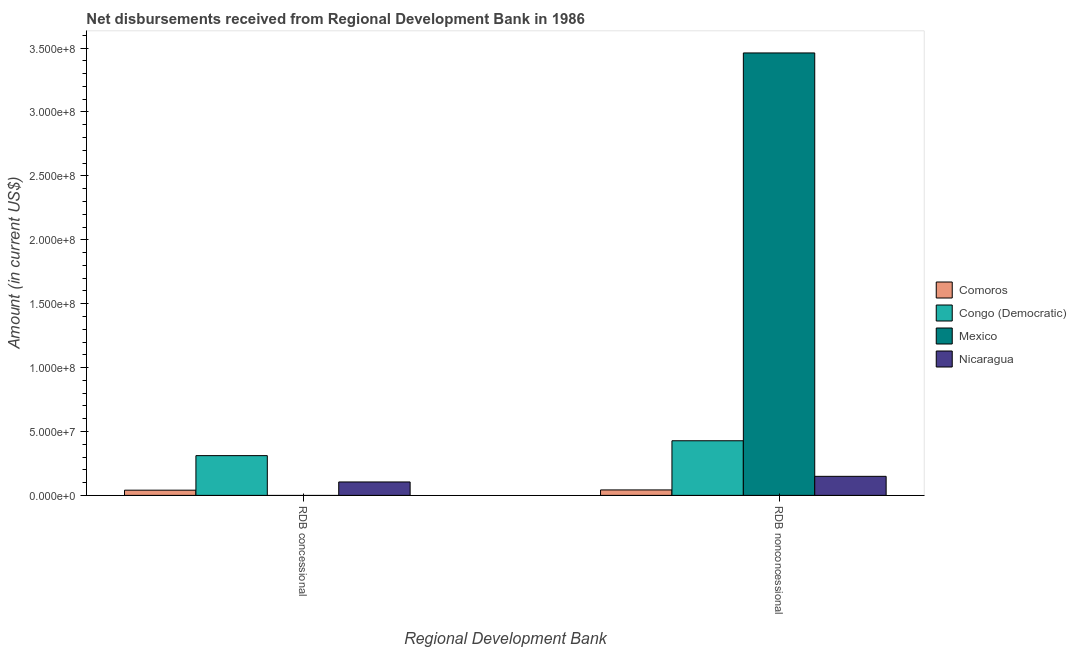Are the number of bars per tick equal to the number of legend labels?
Your answer should be compact. No. Are the number of bars on each tick of the X-axis equal?
Keep it short and to the point. No. How many bars are there on the 1st tick from the left?
Provide a short and direct response. 3. How many bars are there on the 1st tick from the right?
Keep it short and to the point. 4. What is the label of the 2nd group of bars from the left?
Provide a short and direct response. RDB nonconcessional. What is the net non concessional disbursements from rdb in Comoros?
Offer a very short reply. 4.27e+06. Across all countries, what is the maximum net non concessional disbursements from rdb?
Keep it short and to the point. 3.46e+08. In which country was the net concessional disbursements from rdb maximum?
Provide a short and direct response. Congo (Democratic). What is the total net non concessional disbursements from rdb in the graph?
Give a very brief answer. 4.08e+08. What is the difference between the net concessional disbursements from rdb in Nicaragua and that in Comoros?
Your answer should be very brief. 6.43e+06. What is the difference between the net concessional disbursements from rdb in Mexico and the net non concessional disbursements from rdb in Nicaragua?
Provide a succinct answer. -1.49e+07. What is the average net concessional disbursements from rdb per country?
Offer a terse response. 1.14e+07. What is the difference between the net non concessional disbursements from rdb and net concessional disbursements from rdb in Comoros?
Provide a succinct answer. 1.97e+05. What is the ratio of the net non concessional disbursements from rdb in Congo (Democratic) to that in Comoros?
Provide a succinct answer. 10. What is the difference between two consecutive major ticks on the Y-axis?
Keep it short and to the point. 5.00e+07. Are the values on the major ticks of Y-axis written in scientific E-notation?
Make the answer very short. Yes. Does the graph contain any zero values?
Offer a very short reply. Yes. Does the graph contain grids?
Keep it short and to the point. No. How are the legend labels stacked?
Offer a terse response. Vertical. What is the title of the graph?
Give a very brief answer. Net disbursements received from Regional Development Bank in 1986. Does "Tonga" appear as one of the legend labels in the graph?
Give a very brief answer. No. What is the label or title of the X-axis?
Provide a succinct answer. Regional Development Bank. What is the Amount (in current US$) of Comoros in RDB concessional?
Make the answer very short. 4.08e+06. What is the Amount (in current US$) in Congo (Democratic) in RDB concessional?
Give a very brief answer. 3.11e+07. What is the Amount (in current US$) in Mexico in RDB concessional?
Your response must be concise. 0. What is the Amount (in current US$) in Nicaragua in RDB concessional?
Offer a terse response. 1.05e+07. What is the Amount (in current US$) in Comoros in RDB nonconcessional?
Your response must be concise. 4.27e+06. What is the Amount (in current US$) of Congo (Democratic) in RDB nonconcessional?
Your response must be concise. 4.27e+07. What is the Amount (in current US$) in Mexico in RDB nonconcessional?
Make the answer very short. 3.46e+08. What is the Amount (in current US$) of Nicaragua in RDB nonconcessional?
Provide a short and direct response. 1.49e+07. Across all Regional Development Bank, what is the maximum Amount (in current US$) of Comoros?
Provide a short and direct response. 4.27e+06. Across all Regional Development Bank, what is the maximum Amount (in current US$) of Congo (Democratic)?
Your answer should be very brief. 4.27e+07. Across all Regional Development Bank, what is the maximum Amount (in current US$) in Mexico?
Make the answer very short. 3.46e+08. Across all Regional Development Bank, what is the maximum Amount (in current US$) in Nicaragua?
Offer a terse response. 1.49e+07. Across all Regional Development Bank, what is the minimum Amount (in current US$) in Comoros?
Your response must be concise. 4.08e+06. Across all Regional Development Bank, what is the minimum Amount (in current US$) of Congo (Democratic)?
Your response must be concise. 3.11e+07. Across all Regional Development Bank, what is the minimum Amount (in current US$) in Mexico?
Provide a succinct answer. 0. Across all Regional Development Bank, what is the minimum Amount (in current US$) in Nicaragua?
Keep it short and to the point. 1.05e+07. What is the total Amount (in current US$) of Comoros in the graph?
Your answer should be very brief. 8.35e+06. What is the total Amount (in current US$) in Congo (Democratic) in the graph?
Offer a terse response. 7.39e+07. What is the total Amount (in current US$) in Mexico in the graph?
Ensure brevity in your answer.  3.46e+08. What is the total Amount (in current US$) of Nicaragua in the graph?
Make the answer very short. 2.54e+07. What is the difference between the Amount (in current US$) in Comoros in RDB concessional and that in RDB nonconcessional?
Provide a short and direct response. -1.97e+05. What is the difference between the Amount (in current US$) in Congo (Democratic) in RDB concessional and that in RDB nonconcessional?
Give a very brief answer. -1.16e+07. What is the difference between the Amount (in current US$) in Nicaragua in RDB concessional and that in RDB nonconcessional?
Provide a succinct answer. -4.39e+06. What is the difference between the Amount (in current US$) of Comoros in RDB concessional and the Amount (in current US$) of Congo (Democratic) in RDB nonconcessional?
Provide a succinct answer. -3.87e+07. What is the difference between the Amount (in current US$) of Comoros in RDB concessional and the Amount (in current US$) of Mexico in RDB nonconcessional?
Give a very brief answer. -3.42e+08. What is the difference between the Amount (in current US$) of Comoros in RDB concessional and the Amount (in current US$) of Nicaragua in RDB nonconcessional?
Keep it short and to the point. -1.08e+07. What is the difference between the Amount (in current US$) in Congo (Democratic) in RDB concessional and the Amount (in current US$) in Mexico in RDB nonconcessional?
Your answer should be compact. -3.15e+08. What is the difference between the Amount (in current US$) in Congo (Democratic) in RDB concessional and the Amount (in current US$) in Nicaragua in RDB nonconcessional?
Offer a very short reply. 1.62e+07. What is the average Amount (in current US$) in Comoros per Regional Development Bank?
Give a very brief answer. 4.17e+06. What is the average Amount (in current US$) in Congo (Democratic) per Regional Development Bank?
Your response must be concise. 3.69e+07. What is the average Amount (in current US$) of Mexico per Regional Development Bank?
Your answer should be very brief. 1.73e+08. What is the average Amount (in current US$) of Nicaragua per Regional Development Bank?
Provide a short and direct response. 1.27e+07. What is the difference between the Amount (in current US$) in Comoros and Amount (in current US$) in Congo (Democratic) in RDB concessional?
Make the answer very short. -2.70e+07. What is the difference between the Amount (in current US$) in Comoros and Amount (in current US$) in Nicaragua in RDB concessional?
Your answer should be compact. -6.43e+06. What is the difference between the Amount (in current US$) in Congo (Democratic) and Amount (in current US$) in Nicaragua in RDB concessional?
Your answer should be very brief. 2.06e+07. What is the difference between the Amount (in current US$) of Comoros and Amount (in current US$) of Congo (Democratic) in RDB nonconcessional?
Keep it short and to the point. -3.85e+07. What is the difference between the Amount (in current US$) of Comoros and Amount (in current US$) of Mexico in RDB nonconcessional?
Ensure brevity in your answer.  -3.42e+08. What is the difference between the Amount (in current US$) of Comoros and Amount (in current US$) of Nicaragua in RDB nonconcessional?
Offer a very short reply. -1.06e+07. What is the difference between the Amount (in current US$) of Congo (Democratic) and Amount (in current US$) of Mexico in RDB nonconcessional?
Your answer should be compact. -3.03e+08. What is the difference between the Amount (in current US$) of Congo (Democratic) and Amount (in current US$) of Nicaragua in RDB nonconcessional?
Your answer should be compact. 2.78e+07. What is the difference between the Amount (in current US$) in Mexico and Amount (in current US$) in Nicaragua in RDB nonconcessional?
Offer a very short reply. 3.31e+08. What is the ratio of the Amount (in current US$) of Comoros in RDB concessional to that in RDB nonconcessional?
Your response must be concise. 0.95. What is the ratio of the Amount (in current US$) in Congo (Democratic) in RDB concessional to that in RDB nonconcessional?
Provide a short and direct response. 0.73. What is the ratio of the Amount (in current US$) in Nicaragua in RDB concessional to that in RDB nonconcessional?
Offer a terse response. 0.71. What is the difference between the highest and the second highest Amount (in current US$) in Comoros?
Offer a terse response. 1.97e+05. What is the difference between the highest and the second highest Amount (in current US$) of Congo (Democratic)?
Your response must be concise. 1.16e+07. What is the difference between the highest and the second highest Amount (in current US$) of Nicaragua?
Keep it short and to the point. 4.39e+06. What is the difference between the highest and the lowest Amount (in current US$) in Comoros?
Offer a very short reply. 1.97e+05. What is the difference between the highest and the lowest Amount (in current US$) in Congo (Democratic)?
Give a very brief answer. 1.16e+07. What is the difference between the highest and the lowest Amount (in current US$) of Mexico?
Provide a succinct answer. 3.46e+08. What is the difference between the highest and the lowest Amount (in current US$) in Nicaragua?
Make the answer very short. 4.39e+06. 